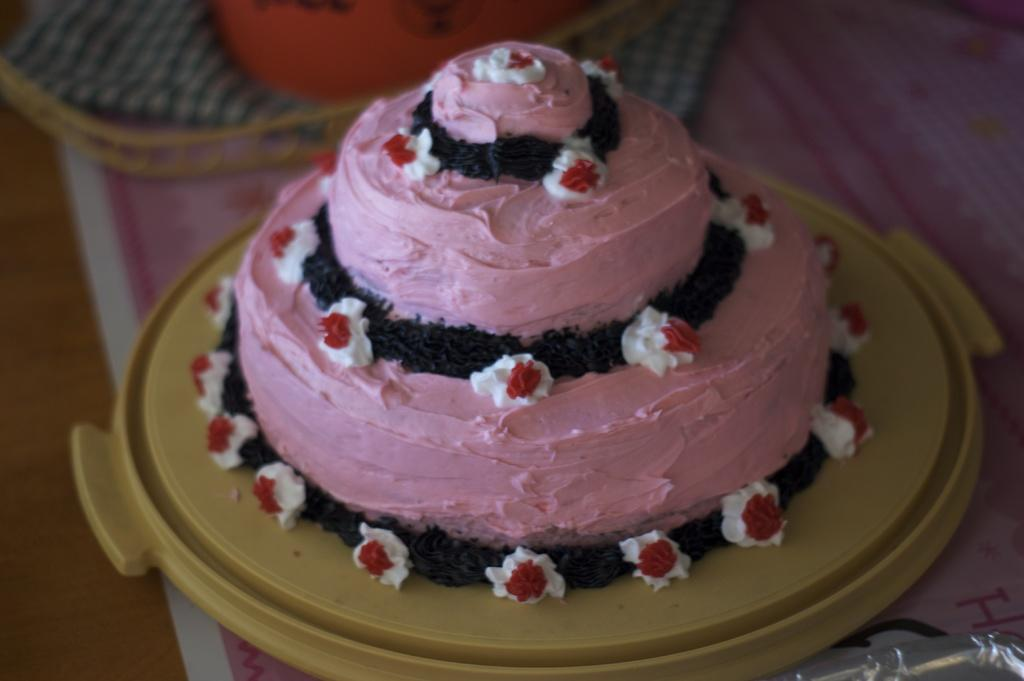What is the main piece of furniture in the image? There is a table in the image. What is placed on the table? There is a paper, a basket with a napkin, and a tray with a cake on the table. Can you describe the cake on the tray? The cake has pink cream on it. What type of arch can be seen in the image? There is no arch present in the image. How much dust is visible on the edge of the table in the image? There is no dust visible on the edge of the table in the image. 